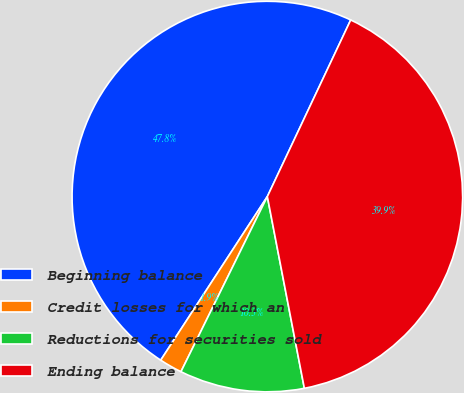Convert chart. <chart><loc_0><loc_0><loc_500><loc_500><pie_chart><fcel>Beginning balance<fcel>Credit losses for which an<fcel>Reductions for securities sold<fcel>Ending balance<nl><fcel>47.83%<fcel>1.9%<fcel>10.33%<fcel>39.95%<nl></chart> 